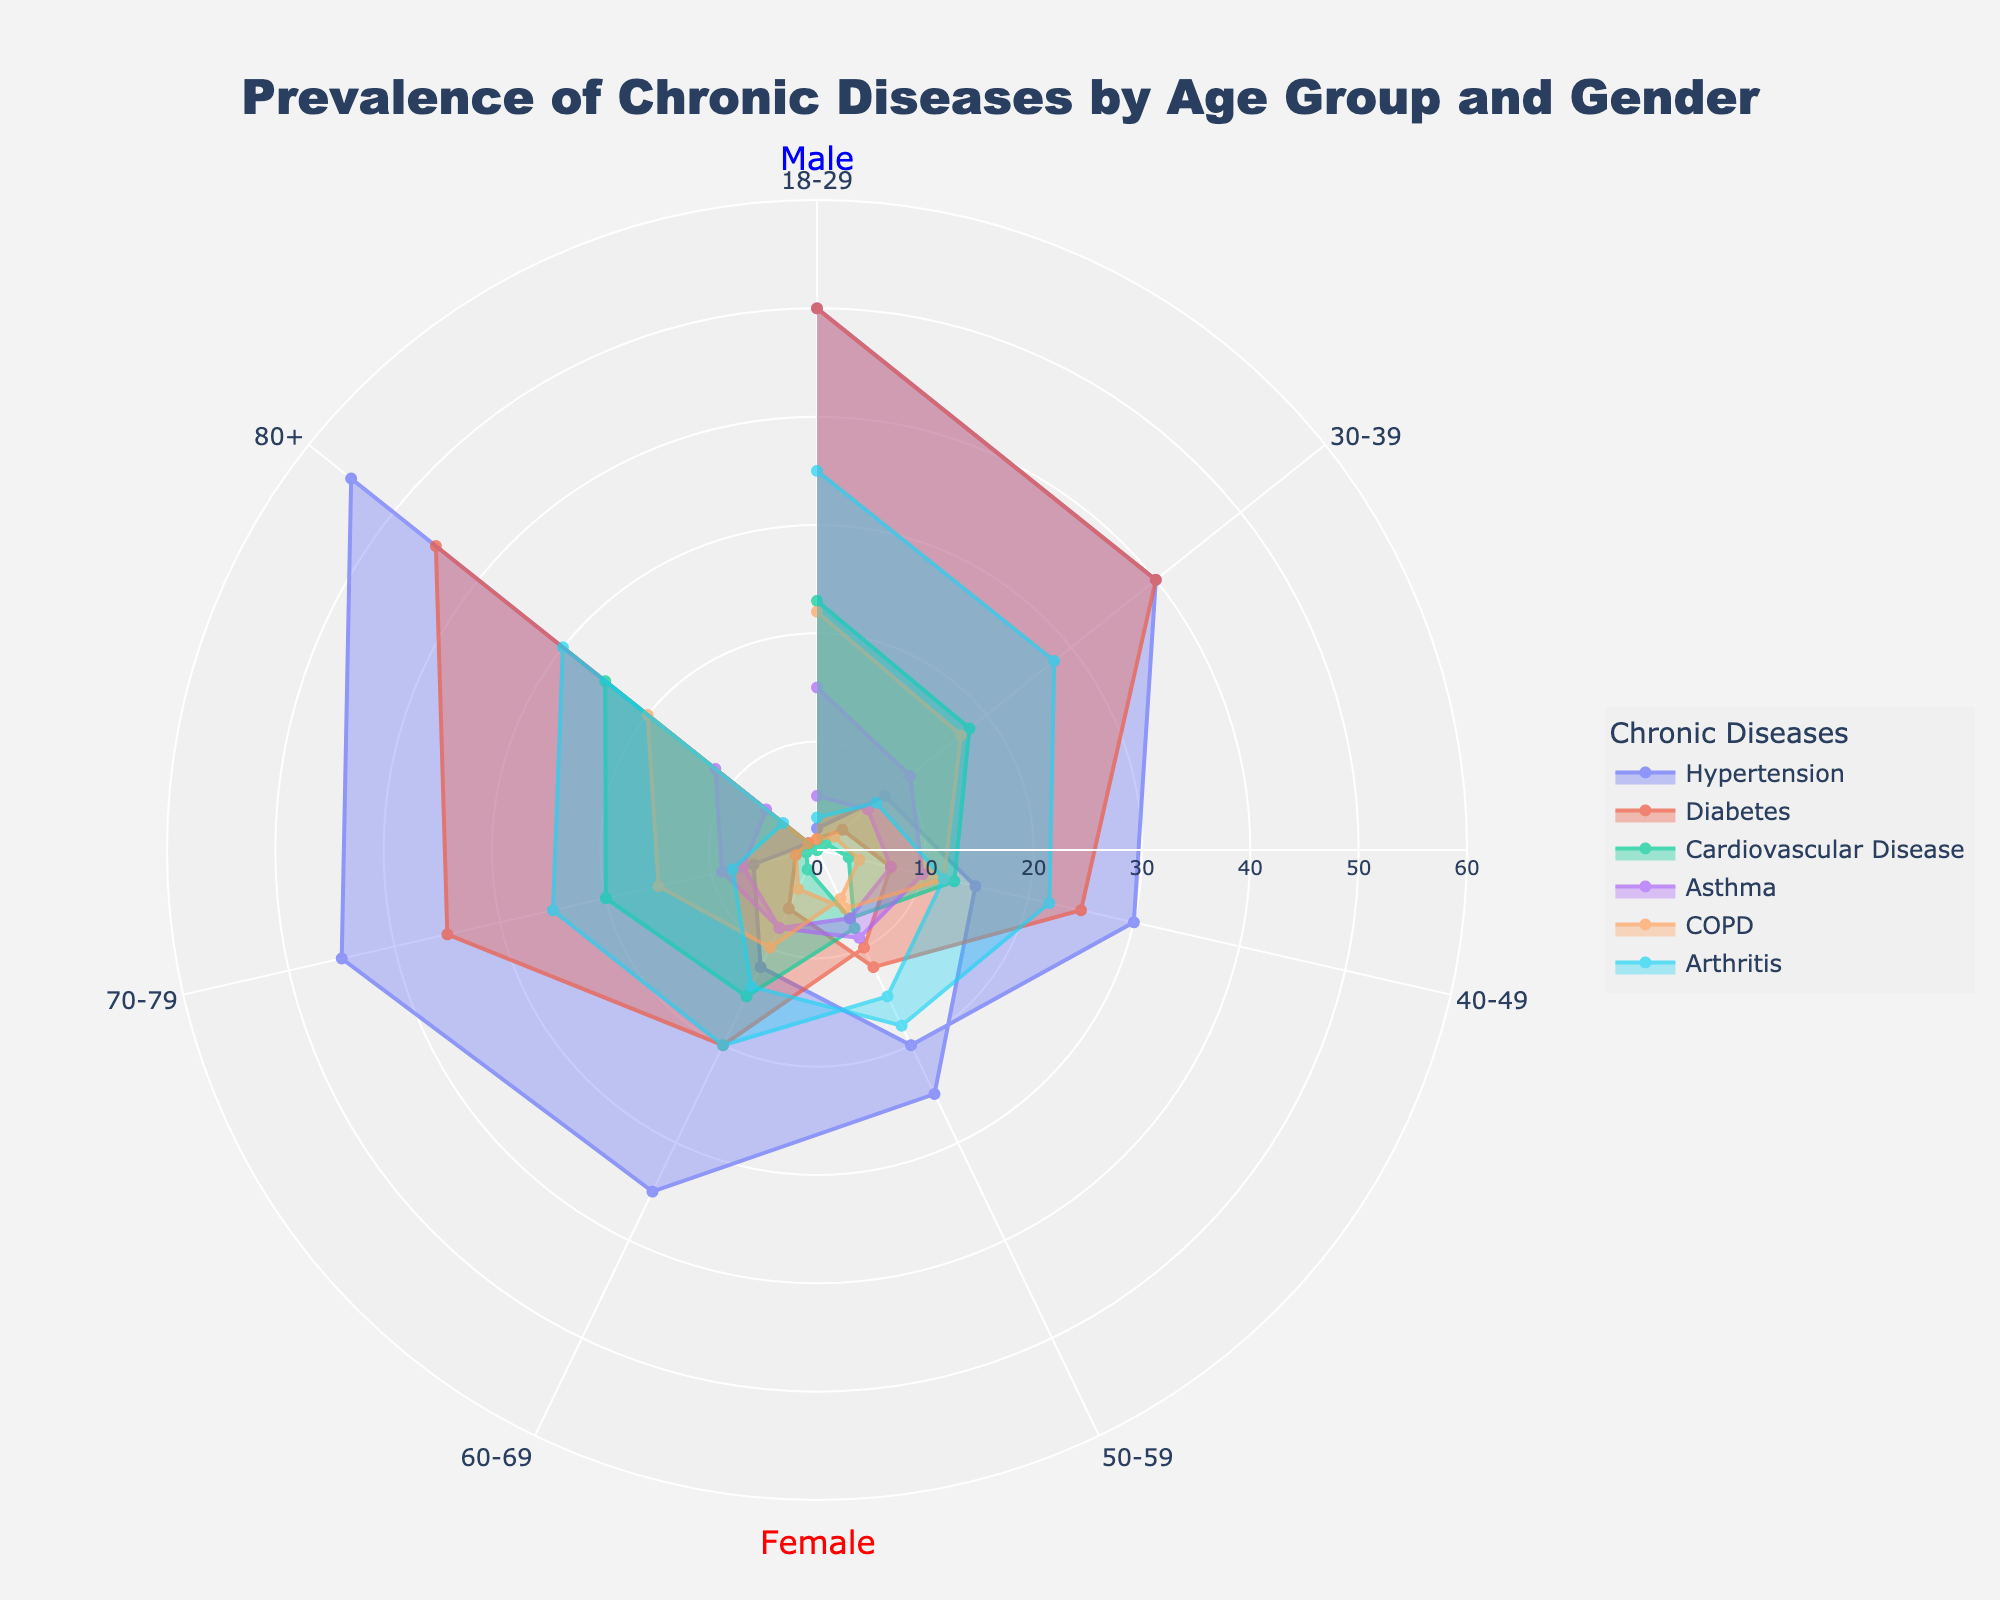What is the title of the chart? The title is located at the top center of the chart and reads clearly, providing the overall subject matter of the chart.
Answer: Prevalence of Chronic Diseases by Age Group and Gender Which age group has the highest prevalence of hypertension among males? Look for the segment representing hypertension in the chart, then identify the age group with the largest radial value for males.
Answer: 80+ How does the prevalence of diabetes compare between 60-69 year-old males and females? Locate the diabetes segments for the 60-69 age group for both genders and compare their radial lengths.
Answer: Females have higher prevalence What is the sum of the prevalence values for Hypertension and Cardiovascular Disease among 50-59 year-old females? Identify values for Hypertension and Cardiovascular Disease in the 50-59 female segment, then sum them up (20 + 7).
Answer: 27 Which chronic disease shows the greatest difference in prevalence between the youngest (18-29) and the oldest (80+) age group for males? For each disease, compare the radial values between 18-29 and 80+ males, and find which has the largest difference.
Answer: Hypertension What general trend can be observed in the prevalence of Arthritis across different age groups? Observe the radial segments for Arthritis across age groups, noting any patterns in the radial lengths.
Answer: Increases with age Which age group shows the highest combined prevalence of COPD across both genders? Sum the male and female COPD prevalence for each age group, and identify the age group with the highest total.
Answer: 80+ Is the prevalence of asthma higher in females or males in the 30-39 age group? Compare the asthma segment for males and females in the 30-39 age group, determining which is longer.
Answer: Female How does the prevalence of cardiovascular disease change with age for females? Look at the segments for cardiovascular disease in each age group for females, identifying the trend in radial lengths.
Answer: Increases with age What is the difference in the prevalence of arthritis between 70-79 year-old males and females? Look at the arthritis values for males and females aged 70-79, and find the difference (28 - 25).
Answer: 3 